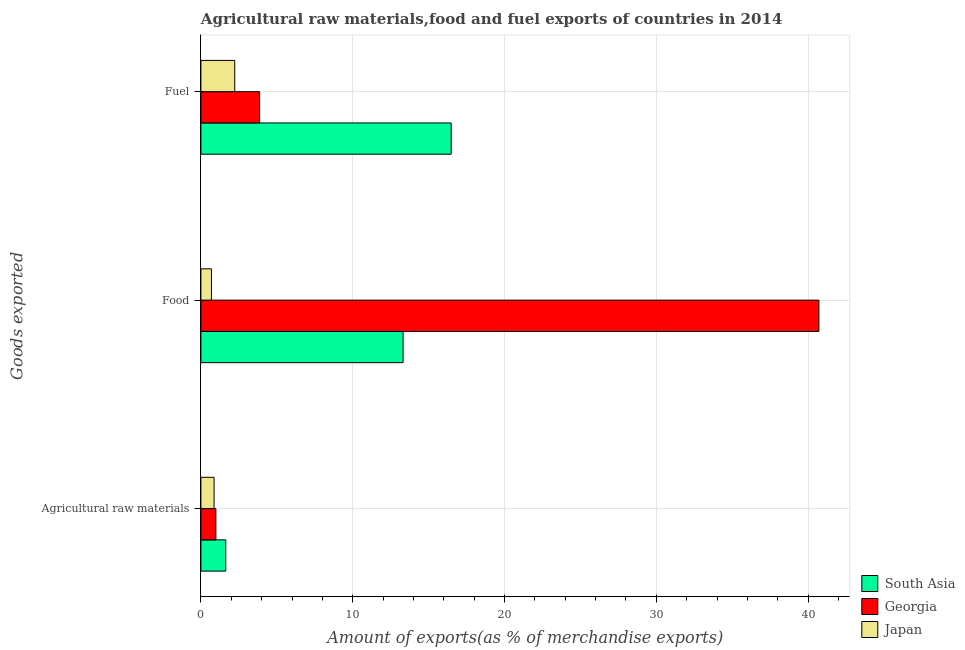Are the number of bars per tick equal to the number of legend labels?
Make the answer very short. Yes. Are the number of bars on each tick of the Y-axis equal?
Your response must be concise. Yes. How many bars are there on the 1st tick from the top?
Give a very brief answer. 3. How many bars are there on the 2nd tick from the bottom?
Make the answer very short. 3. What is the label of the 1st group of bars from the top?
Make the answer very short. Fuel. What is the percentage of fuel exports in Georgia?
Ensure brevity in your answer.  3.87. Across all countries, what is the maximum percentage of raw materials exports?
Offer a very short reply. 1.64. Across all countries, what is the minimum percentage of raw materials exports?
Make the answer very short. 0.87. In which country was the percentage of fuel exports minimum?
Offer a very short reply. Japan. What is the total percentage of fuel exports in the graph?
Your response must be concise. 22.58. What is the difference between the percentage of raw materials exports in Georgia and that in Japan?
Provide a succinct answer. 0.12. What is the difference between the percentage of fuel exports in Japan and the percentage of raw materials exports in South Asia?
Your answer should be compact. 0.59. What is the average percentage of food exports per country?
Ensure brevity in your answer.  18.24. What is the difference between the percentage of food exports and percentage of raw materials exports in South Asia?
Your answer should be compact. 11.68. What is the ratio of the percentage of food exports in Georgia to that in South Asia?
Ensure brevity in your answer.  3.06. Is the percentage of fuel exports in Japan less than that in Georgia?
Provide a succinct answer. Yes. What is the difference between the highest and the second highest percentage of fuel exports?
Your response must be concise. 12.62. What is the difference between the highest and the lowest percentage of raw materials exports?
Keep it short and to the point. 0.77. Is the sum of the percentage of fuel exports in Georgia and Japan greater than the maximum percentage of raw materials exports across all countries?
Your response must be concise. Yes. What does the 2nd bar from the bottom in Agricultural raw materials represents?
Your answer should be compact. Georgia. Are all the bars in the graph horizontal?
Your answer should be very brief. Yes. Are the values on the major ticks of X-axis written in scientific E-notation?
Provide a short and direct response. No. Does the graph contain grids?
Give a very brief answer. Yes. Where does the legend appear in the graph?
Keep it short and to the point. Bottom right. How many legend labels are there?
Your answer should be very brief. 3. What is the title of the graph?
Offer a very short reply. Agricultural raw materials,food and fuel exports of countries in 2014. What is the label or title of the X-axis?
Make the answer very short. Amount of exports(as % of merchandise exports). What is the label or title of the Y-axis?
Offer a very short reply. Goods exported. What is the Amount of exports(as % of merchandise exports) in South Asia in Agricultural raw materials?
Your answer should be compact. 1.64. What is the Amount of exports(as % of merchandise exports) of Georgia in Agricultural raw materials?
Your response must be concise. 0.99. What is the Amount of exports(as % of merchandise exports) of Japan in Agricultural raw materials?
Your answer should be very brief. 0.87. What is the Amount of exports(as % of merchandise exports) of South Asia in Food?
Offer a very short reply. 13.32. What is the Amount of exports(as % of merchandise exports) of Georgia in Food?
Your answer should be very brief. 40.71. What is the Amount of exports(as % of merchandise exports) in Japan in Food?
Make the answer very short. 0.69. What is the Amount of exports(as % of merchandise exports) in South Asia in Fuel?
Offer a very short reply. 16.49. What is the Amount of exports(as % of merchandise exports) of Georgia in Fuel?
Offer a very short reply. 3.87. What is the Amount of exports(as % of merchandise exports) of Japan in Fuel?
Offer a terse response. 2.23. Across all Goods exported, what is the maximum Amount of exports(as % of merchandise exports) of South Asia?
Provide a short and direct response. 16.49. Across all Goods exported, what is the maximum Amount of exports(as % of merchandise exports) in Georgia?
Ensure brevity in your answer.  40.71. Across all Goods exported, what is the maximum Amount of exports(as % of merchandise exports) of Japan?
Ensure brevity in your answer.  2.23. Across all Goods exported, what is the minimum Amount of exports(as % of merchandise exports) of South Asia?
Keep it short and to the point. 1.64. Across all Goods exported, what is the minimum Amount of exports(as % of merchandise exports) in Georgia?
Your response must be concise. 0.99. Across all Goods exported, what is the minimum Amount of exports(as % of merchandise exports) in Japan?
Ensure brevity in your answer.  0.69. What is the total Amount of exports(as % of merchandise exports) in South Asia in the graph?
Provide a short and direct response. 31.44. What is the total Amount of exports(as % of merchandise exports) of Georgia in the graph?
Your response must be concise. 45.56. What is the total Amount of exports(as % of merchandise exports) of Japan in the graph?
Your answer should be very brief. 3.79. What is the difference between the Amount of exports(as % of merchandise exports) of South Asia in Agricultural raw materials and that in Food?
Ensure brevity in your answer.  -11.68. What is the difference between the Amount of exports(as % of merchandise exports) in Georgia in Agricultural raw materials and that in Food?
Your response must be concise. -39.73. What is the difference between the Amount of exports(as % of merchandise exports) in Japan in Agricultural raw materials and that in Food?
Your answer should be compact. 0.17. What is the difference between the Amount of exports(as % of merchandise exports) in South Asia in Agricultural raw materials and that in Fuel?
Ensure brevity in your answer.  -14.85. What is the difference between the Amount of exports(as % of merchandise exports) in Georgia in Agricultural raw materials and that in Fuel?
Offer a terse response. -2.88. What is the difference between the Amount of exports(as % of merchandise exports) of Japan in Agricultural raw materials and that in Fuel?
Your answer should be very brief. -1.36. What is the difference between the Amount of exports(as % of merchandise exports) in South Asia in Food and that in Fuel?
Your response must be concise. -3.17. What is the difference between the Amount of exports(as % of merchandise exports) of Georgia in Food and that in Fuel?
Your answer should be compact. 36.84. What is the difference between the Amount of exports(as % of merchandise exports) in Japan in Food and that in Fuel?
Provide a short and direct response. -1.53. What is the difference between the Amount of exports(as % of merchandise exports) of South Asia in Agricultural raw materials and the Amount of exports(as % of merchandise exports) of Georgia in Food?
Give a very brief answer. -39.07. What is the difference between the Amount of exports(as % of merchandise exports) in South Asia in Agricultural raw materials and the Amount of exports(as % of merchandise exports) in Japan in Food?
Provide a short and direct response. 0.94. What is the difference between the Amount of exports(as % of merchandise exports) in Georgia in Agricultural raw materials and the Amount of exports(as % of merchandise exports) in Japan in Food?
Make the answer very short. 0.29. What is the difference between the Amount of exports(as % of merchandise exports) of South Asia in Agricultural raw materials and the Amount of exports(as % of merchandise exports) of Georgia in Fuel?
Ensure brevity in your answer.  -2.23. What is the difference between the Amount of exports(as % of merchandise exports) in South Asia in Agricultural raw materials and the Amount of exports(as % of merchandise exports) in Japan in Fuel?
Give a very brief answer. -0.59. What is the difference between the Amount of exports(as % of merchandise exports) of Georgia in Agricultural raw materials and the Amount of exports(as % of merchandise exports) of Japan in Fuel?
Your answer should be very brief. -1.24. What is the difference between the Amount of exports(as % of merchandise exports) of South Asia in Food and the Amount of exports(as % of merchandise exports) of Georgia in Fuel?
Your answer should be very brief. 9.45. What is the difference between the Amount of exports(as % of merchandise exports) of South Asia in Food and the Amount of exports(as % of merchandise exports) of Japan in Fuel?
Your response must be concise. 11.09. What is the difference between the Amount of exports(as % of merchandise exports) of Georgia in Food and the Amount of exports(as % of merchandise exports) of Japan in Fuel?
Keep it short and to the point. 38.48. What is the average Amount of exports(as % of merchandise exports) in South Asia per Goods exported?
Make the answer very short. 10.48. What is the average Amount of exports(as % of merchandise exports) in Georgia per Goods exported?
Give a very brief answer. 15.19. What is the average Amount of exports(as % of merchandise exports) in Japan per Goods exported?
Make the answer very short. 1.26. What is the difference between the Amount of exports(as % of merchandise exports) in South Asia and Amount of exports(as % of merchandise exports) in Georgia in Agricultural raw materials?
Your answer should be compact. 0.65. What is the difference between the Amount of exports(as % of merchandise exports) of South Asia and Amount of exports(as % of merchandise exports) of Japan in Agricultural raw materials?
Make the answer very short. 0.77. What is the difference between the Amount of exports(as % of merchandise exports) in Georgia and Amount of exports(as % of merchandise exports) in Japan in Agricultural raw materials?
Offer a terse response. 0.12. What is the difference between the Amount of exports(as % of merchandise exports) of South Asia and Amount of exports(as % of merchandise exports) of Georgia in Food?
Make the answer very short. -27.39. What is the difference between the Amount of exports(as % of merchandise exports) of South Asia and Amount of exports(as % of merchandise exports) of Japan in Food?
Ensure brevity in your answer.  12.63. What is the difference between the Amount of exports(as % of merchandise exports) in Georgia and Amount of exports(as % of merchandise exports) in Japan in Food?
Keep it short and to the point. 40.02. What is the difference between the Amount of exports(as % of merchandise exports) of South Asia and Amount of exports(as % of merchandise exports) of Georgia in Fuel?
Your response must be concise. 12.62. What is the difference between the Amount of exports(as % of merchandise exports) of South Asia and Amount of exports(as % of merchandise exports) of Japan in Fuel?
Provide a short and direct response. 14.26. What is the difference between the Amount of exports(as % of merchandise exports) in Georgia and Amount of exports(as % of merchandise exports) in Japan in Fuel?
Provide a short and direct response. 1.64. What is the ratio of the Amount of exports(as % of merchandise exports) in South Asia in Agricultural raw materials to that in Food?
Give a very brief answer. 0.12. What is the ratio of the Amount of exports(as % of merchandise exports) in Georgia in Agricultural raw materials to that in Food?
Your answer should be very brief. 0.02. What is the ratio of the Amount of exports(as % of merchandise exports) in Japan in Agricultural raw materials to that in Food?
Give a very brief answer. 1.25. What is the ratio of the Amount of exports(as % of merchandise exports) in South Asia in Agricultural raw materials to that in Fuel?
Your response must be concise. 0.1. What is the ratio of the Amount of exports(as % of merchandise exports) in Georgia in Agricultural raw materials to that in Fuel?
Offer a very short reply. 0.25. What is the ratio of the Amount of exports(as % of merchandise exports) in Japan in Agricultural raw materials to that in Fuel?
Make the answer very short. 0.39. What is the ratio of the Amount of exports(as % of merchandise exports) in South Asia in Food to that in Fuel?
Provide a short and direct response. 0.81. What is the ratio of the Amount of exports(as % of merchandise exports) of Georgia in Food to that in Fuel?
Ensure brevity in your answer.  10.53. What is the ratio of the Amount of exports(as % of merchandise exports) in Japan in Food to that in Fuel?
Ensure brevity in your answer.  0.31. What is the difference between the highest and the second highest Amount of exports(as % of merchandise exports) in South Asia?
Give a very brief answer. 3.17. What is the difference between the highest and the second highest Amount of exports(as % of merchandise exports) in Georgia?
Your answer should be very brief. 36.84. What is the difference between the highest and the second highest Amount of exports(as % of merchandise exports) in Japan?
Keep it short and to the point. 1.36. What is the difference between the highest and the lowest Amount of exports(as % of merchandise exports) in South Asia?
Your answer should be compact. 14.85. What is the difference between the highest and the lowest Amount of exports(as % of merchandise exports) in Georgia?
Your answer should be very brief. 39.73. What is the difference between the highest and the lowest Amount of exports(as % of merchandise exports) in Japan?
Give a very brief answer. 1.53. 